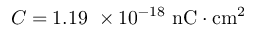Convert formula to latex. <formula><loc_0><loc_0><loc_500><loc_500>C = 1 . 1 9 \ \times 1 0 ^ { - 1 8 } \ n C \cdot c m ^ { 2 }</formula> 